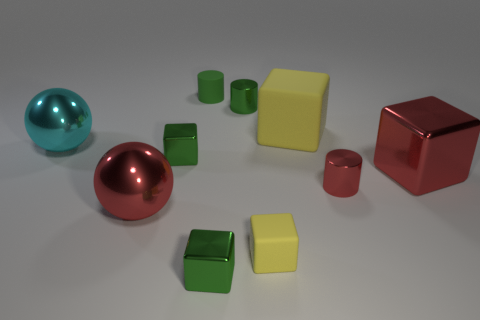Subtract all green cylinders. How many were subtracted if there are1green cylinders left? 1 Subtract all green blocks. How many blocks are left? 3 Subtract all green cylinders. How many cylinders are left? 1 Subtract 1 cubes. How many cubes are left? 4 Subtract all green cubes. Subtract all yellow spheres. How many cubes are left? 3 Subtract all yellow spheres. How many red blocks are left? 1 Subtract all big yellow rubber cylinders. Subtract all big cyan shiny spheres. How many objects are left? 9 Add 8 green cylinders. How many green cylinders are left? 10 Add 4 matte blocks. How many matte blocks exist? 6 Subtract 2 green cylinders. How many objects are left? 8 